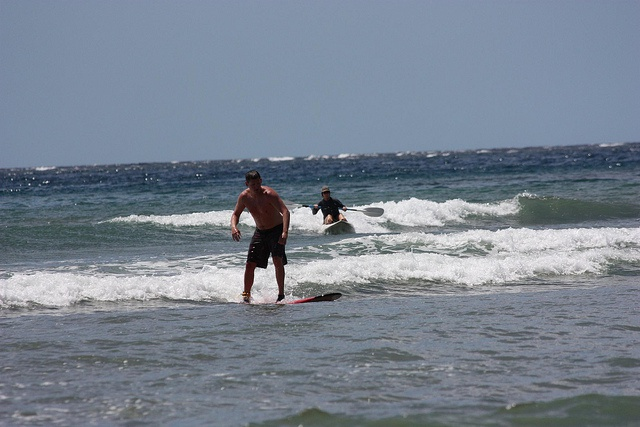Describe the objects in this image and their specific colors. I can see people in gray, black, maroon, and brown tones, people in gray, black, maroon, and darkgray tones, surfboard in gray, black, and darkgray tones, and surfboard in gray, black, lightgray, and darkgray tones in this image. 